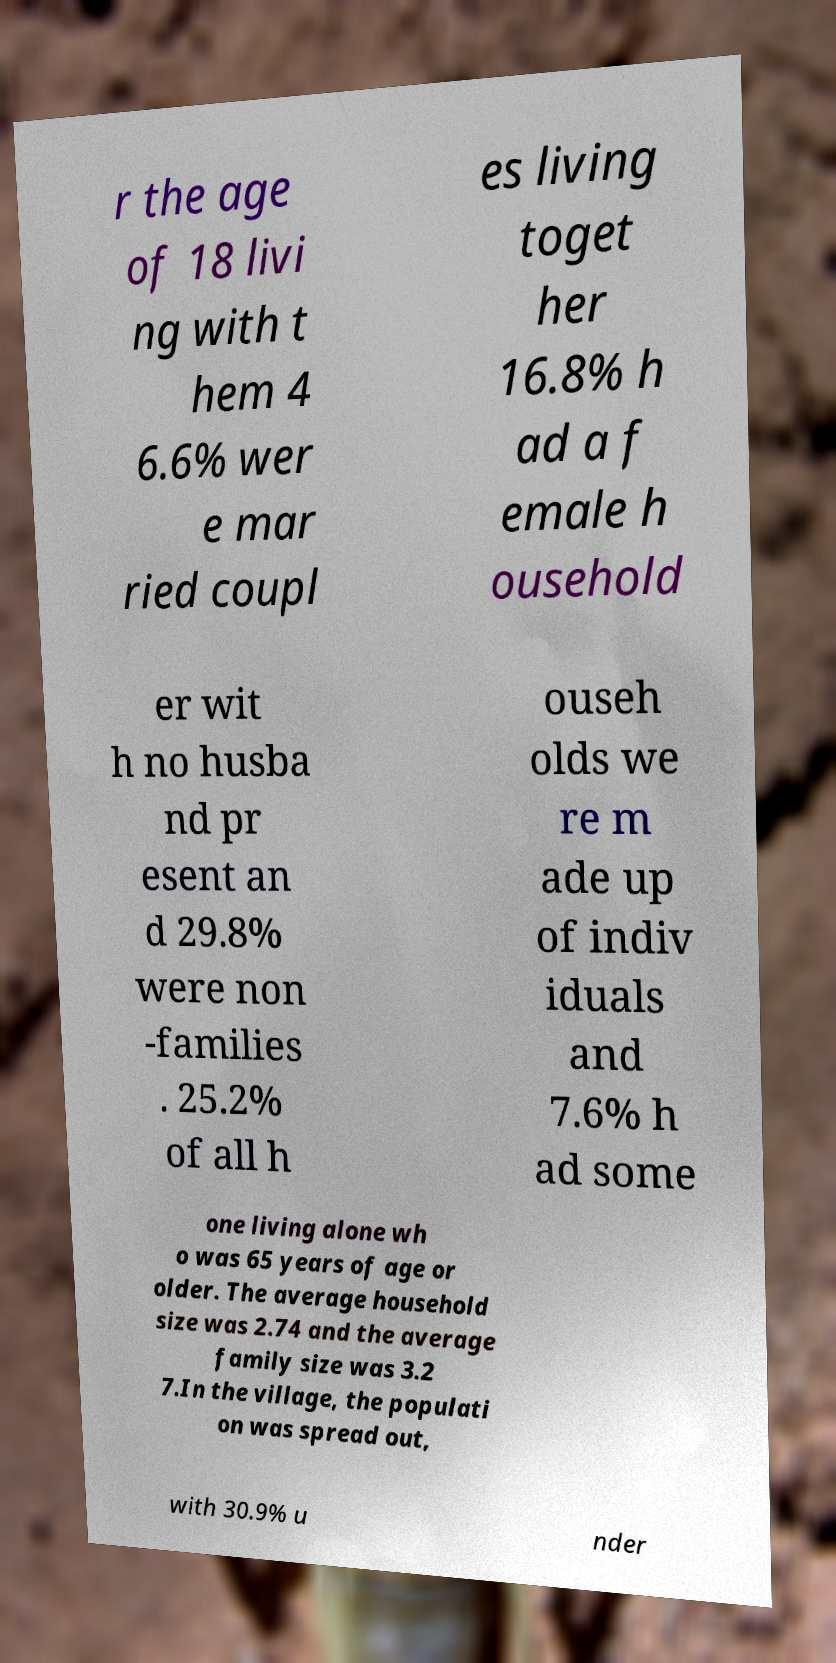Please read and relay the text visible in this image. What does it say? r the age of 18 livi ng with t hem 4 6.6% wer e mar ried coupl es living toget her 16.8% h ad a f emale h ousehold er wit h no husba nd pr esent an d 29.8% were non -families . 25.2% of all h ouseh olds we re m ade up of indiv iduals and 7.6% h ad some one living alone wh o was 65 years of age or older. The average household size was 2.74 and the average family size was 3.2 7.In the village, the populati on was spread out, with 30.9% u nder 